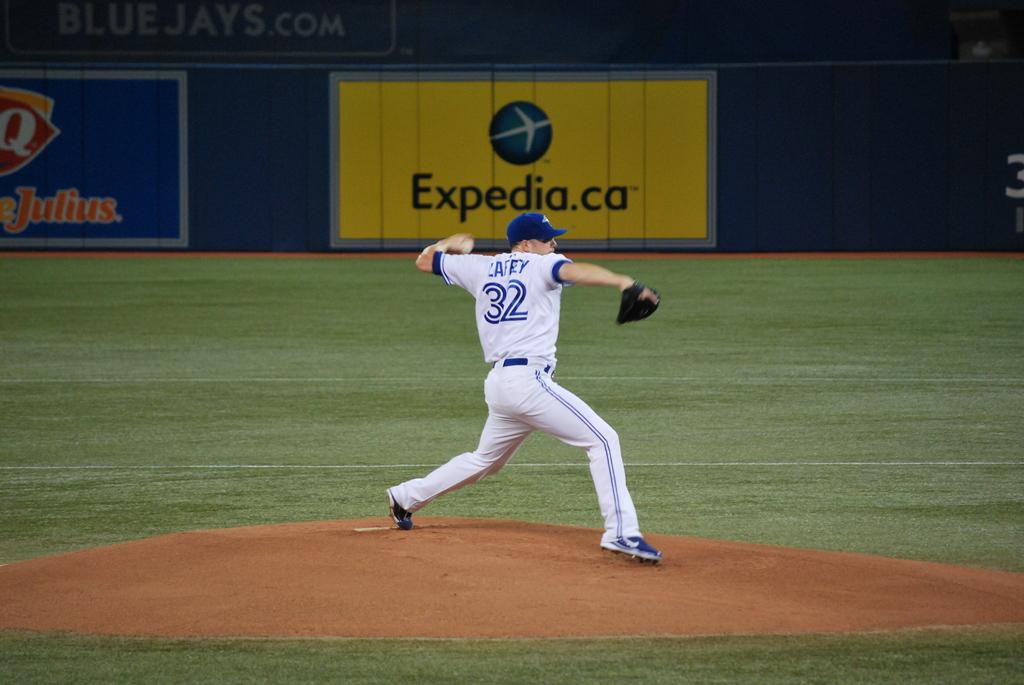Provide a one-sentence caption for the provided image. Number 32 in a white and blue trimmed uniform winding up for the pitch. 